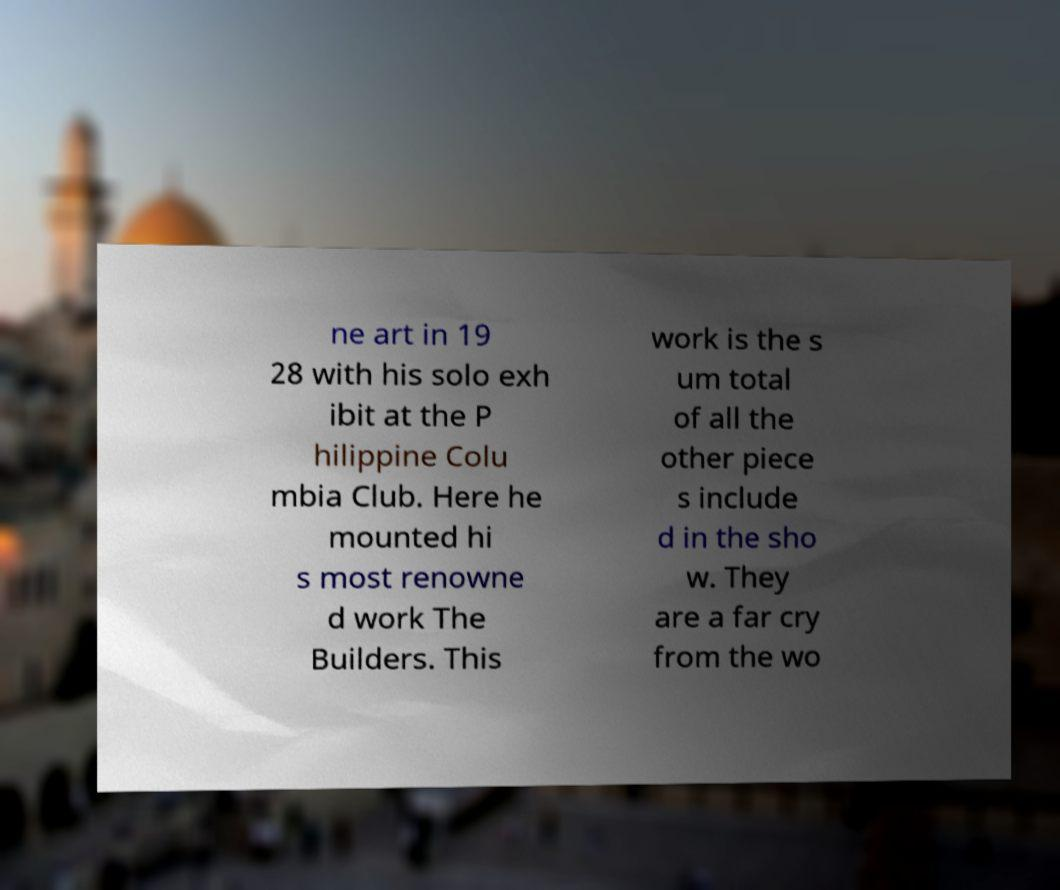Please read and relay the text visible in this image. What does it say? ne art in 19 28 with his solo exh ibit at the P hilippine Colu mbia Club. Here he mounted hi s most renowne d work The Builders. This work is the s um total of all the other piece s include d in the sho w. They are a far cry from the wo 